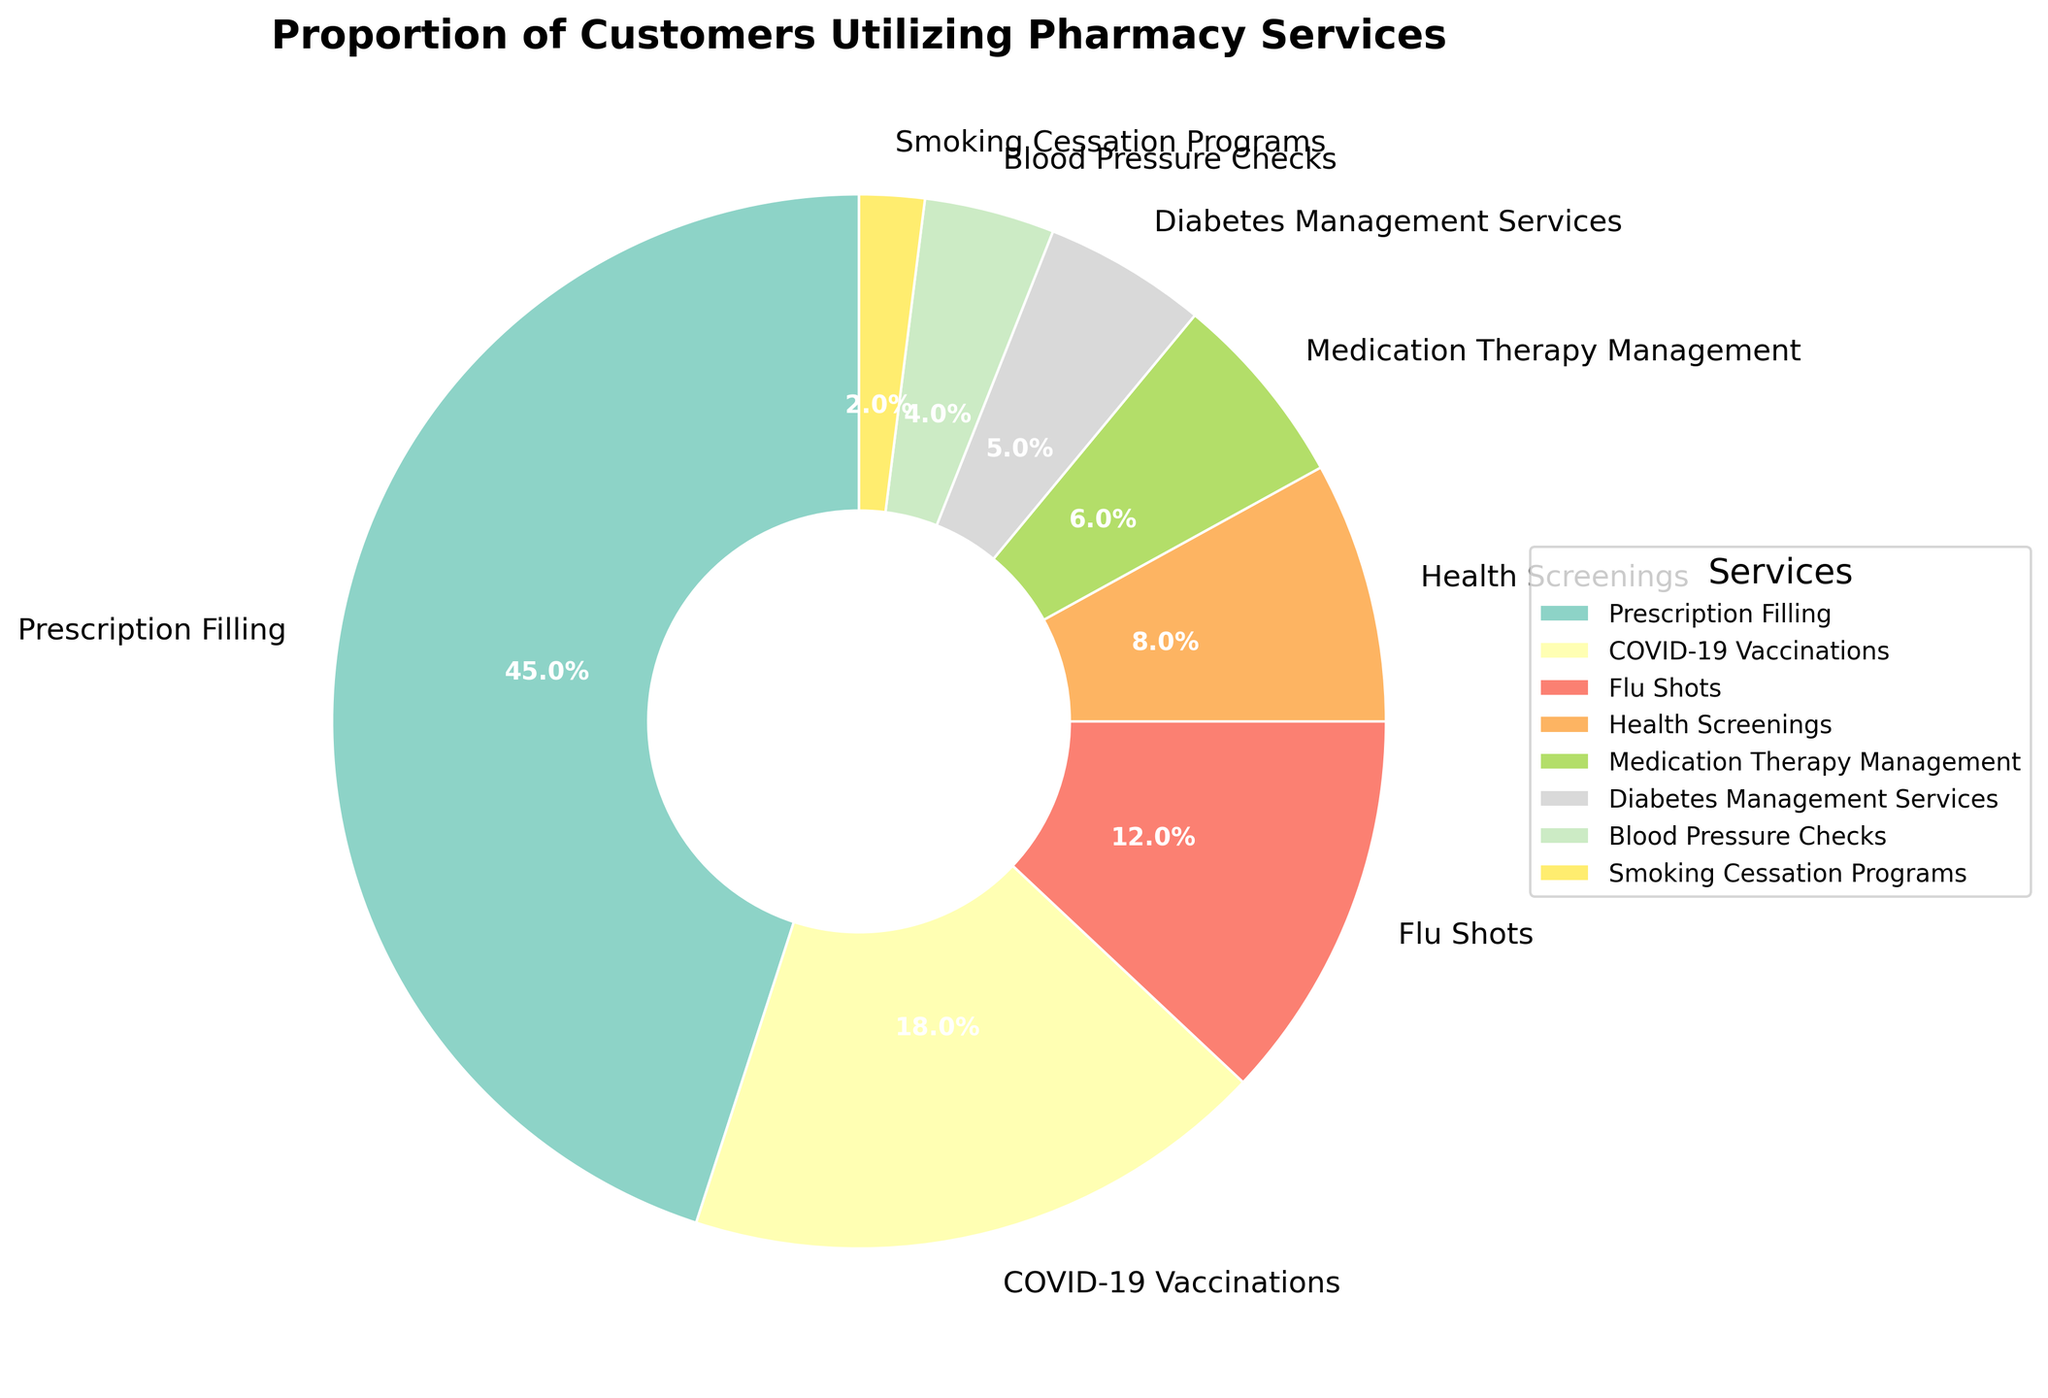Which service is utilized by the highest percentage of customers? The slice labeled "Prescription Filling" occupies the largest portion of the pie chart with a percentage displayed as 45%.
Answer: Prescription Filling Which two services collectively account for more than half of the customers? By summing the percentages of the two largest sections, Prescription Filling (45%) and COVID-19 Vaccinations (18%), which give a total of 63%, greater than 50%.
Answer: Prescription Filling and COVID-19 Vaccinations Is the proportion of customers using Health Screenings higher than those using Medication Therapy Management? The pie chart shows that Health Screenings has a portion labeled 8%, and Medication Therapy Management has a portion labeled 6%, indicating Health Screenings is higher.
Answer: Yes Among Flu Shots and Diabetes Management Services, which has fewer customers? The section labeled Flu Shots shows 12%, while Diabetes Management Services is 5%, making Diabetes Management Services lower.
Answer: Diabetes Management Services What is the combined percentage of customers using either Blood Pressure Checks or Smoking Cessation Programs but not both? Add the percentages for Blood Pressure Checks (4%) and Smoking Cessation Programs (2%) to get the combined percentage of customers using either service.
Answer: 6% What percentage of customers use services other than Prescription Filling? By subtracting the Prescription Filling percentage (45%) from the total (100%) to find customers using other services.
Answer: 55% Which service has the smallest proportion of customers? The smallest slice on the pie chart is labeled "Smoking Cessation Programs," with a percentage shown as 2%.
Answer: Smoking Cessation Programs Determine the difference in customer proportion between Flu Shots and Health Screenings. Subtract Health Screenings' percentage (8%) from Flu Shots' percentage (12%) to find the difference.
Answer: 4% Are there more customers utilizing COVID-19 Vaccinations or all services other than COVID-19 Vaccinations combined? The percentage for COVID-19 Vaccinations is 18%. Subtract the COVID-19 Vaccinations percentage from 100% to find others (82%). 82% is greater than 18%.
Answer: All other services combined Compare the proportion of customers using Medication Therapy Management to those using Diabetes Management Services and Blood Pressure Checks together. Sum the percentages of Diabetes Management Services (5%) and Blood Pressure Checks (4%) to get 9%. 9% is greater than Medication Therapy Management’s 6%.
Answer: Diabetes Management Services and Blood Pressure Checks together 